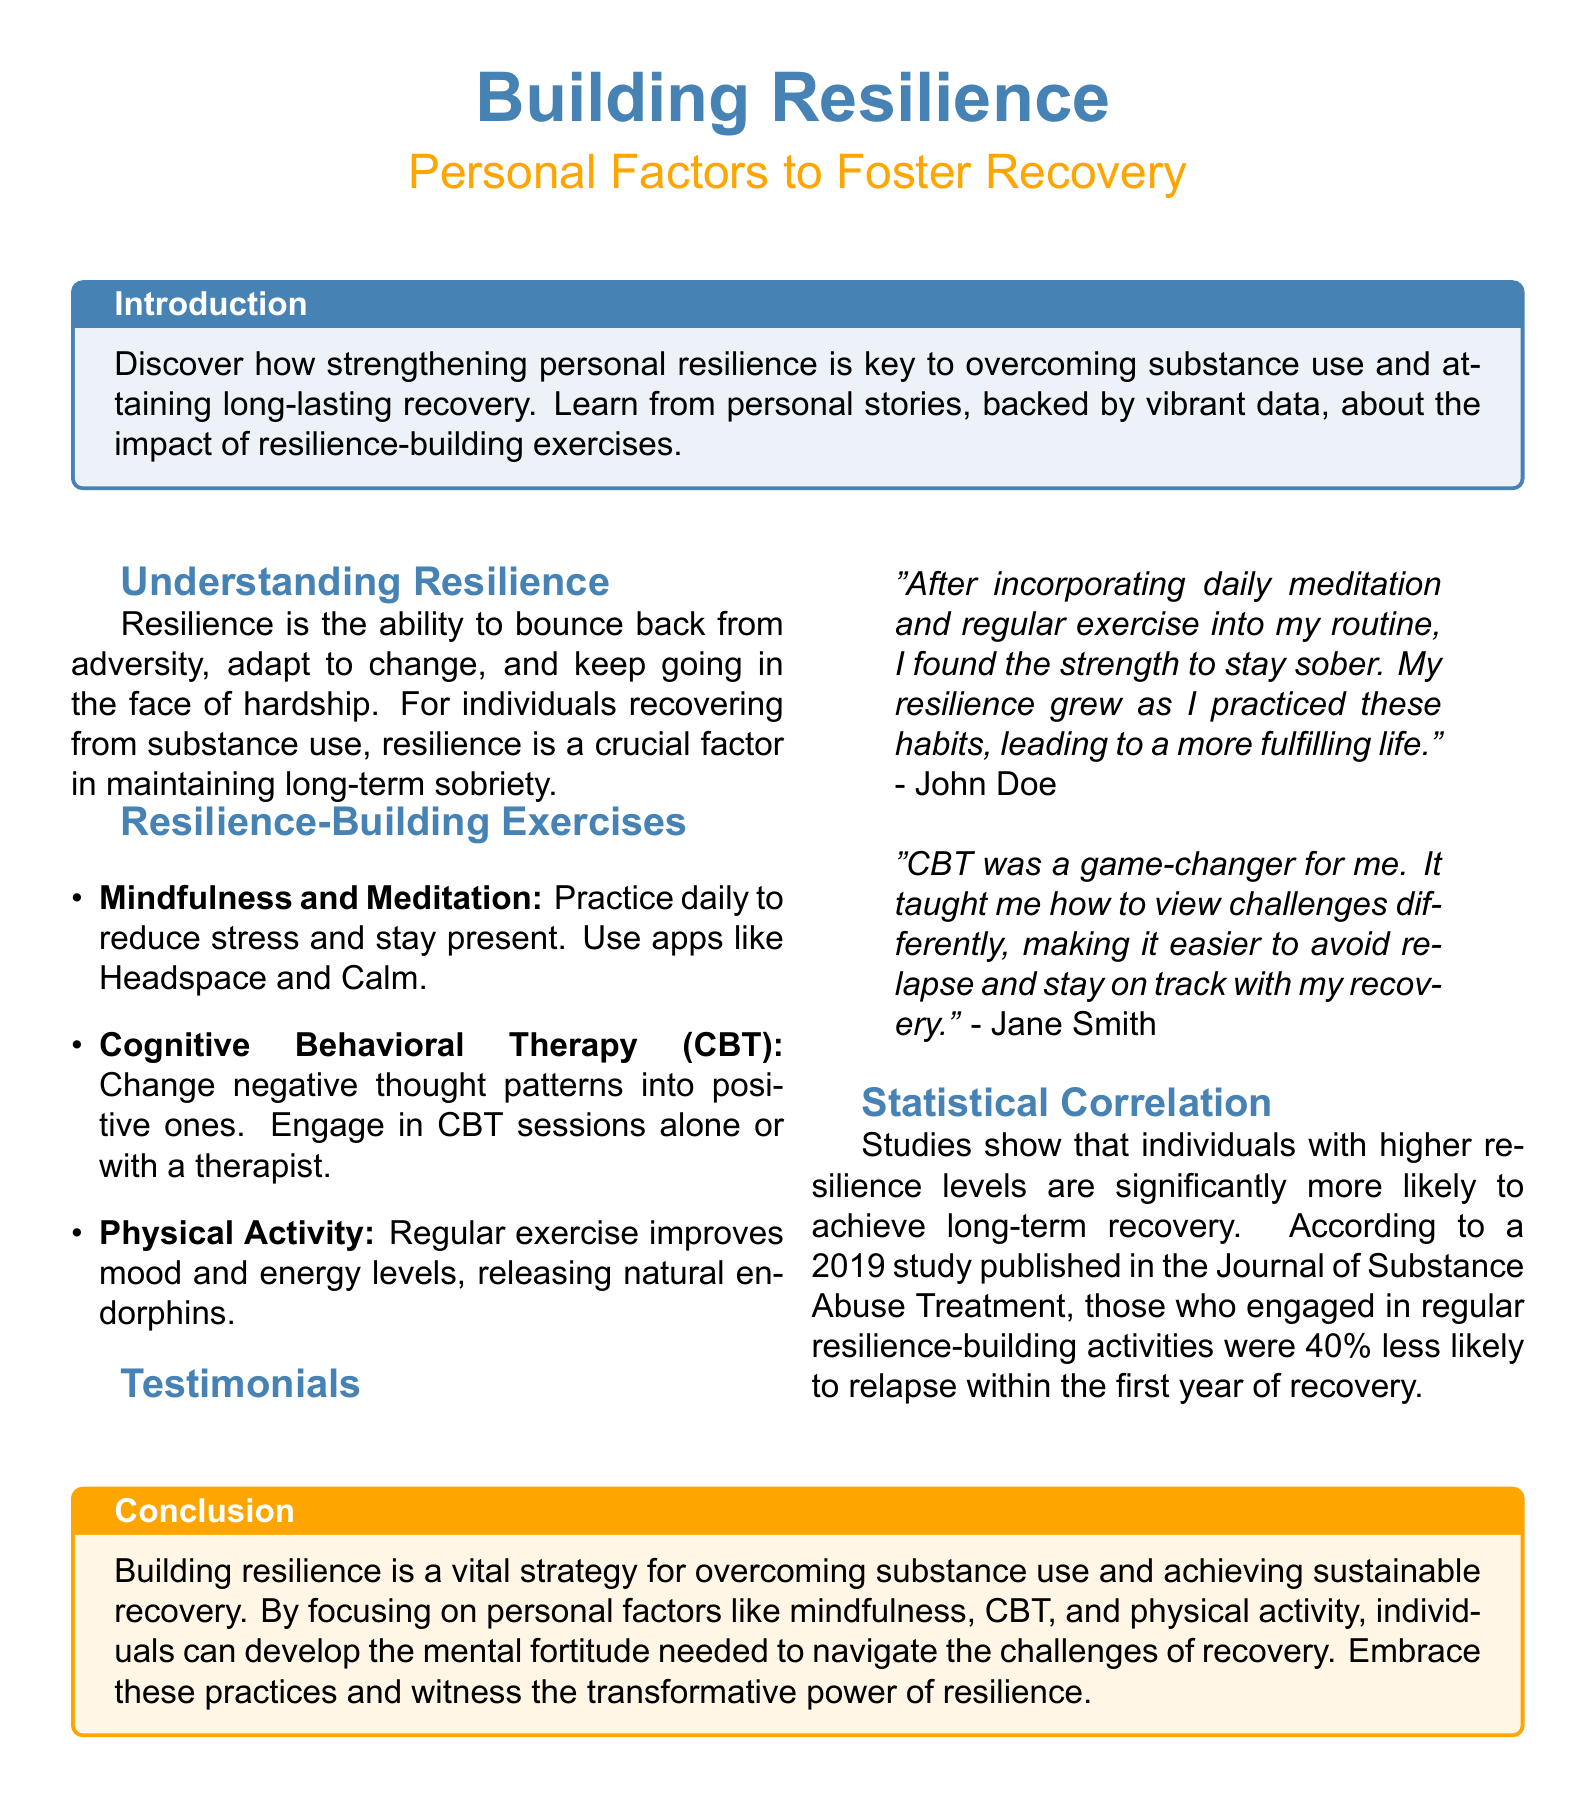What is the main topic of the flyer? The main topic of the flyer is about building resilience and personal factors to foster recovery from substance use.
Answer: Building Resilience What exercise is recommended for stress reduction? The flyer suggests practicing mindfulness and meditation to reduce stress.
Answer: Mindfulness and Meditation What percentage less likely are individuals engaged in resilience-building activities to relapse? According to the document, individuals engaged in resilience-building activities are 40% less likely to relapse within the first year of recovery.
Answer: 40% Who is a testimonial provided in the flyer? The flyer includes testimonials from John Doe and Jane Smith regarding their experiences with resilience-building exercises.
Answer: John Doe, Jane Smith What is a key benefit of regular physical activity mentioned in the document? Regular exercise improves mood and energy levels, releasing natural endorphins, according to the flyer.
Answer: Improves mood and energy levels 